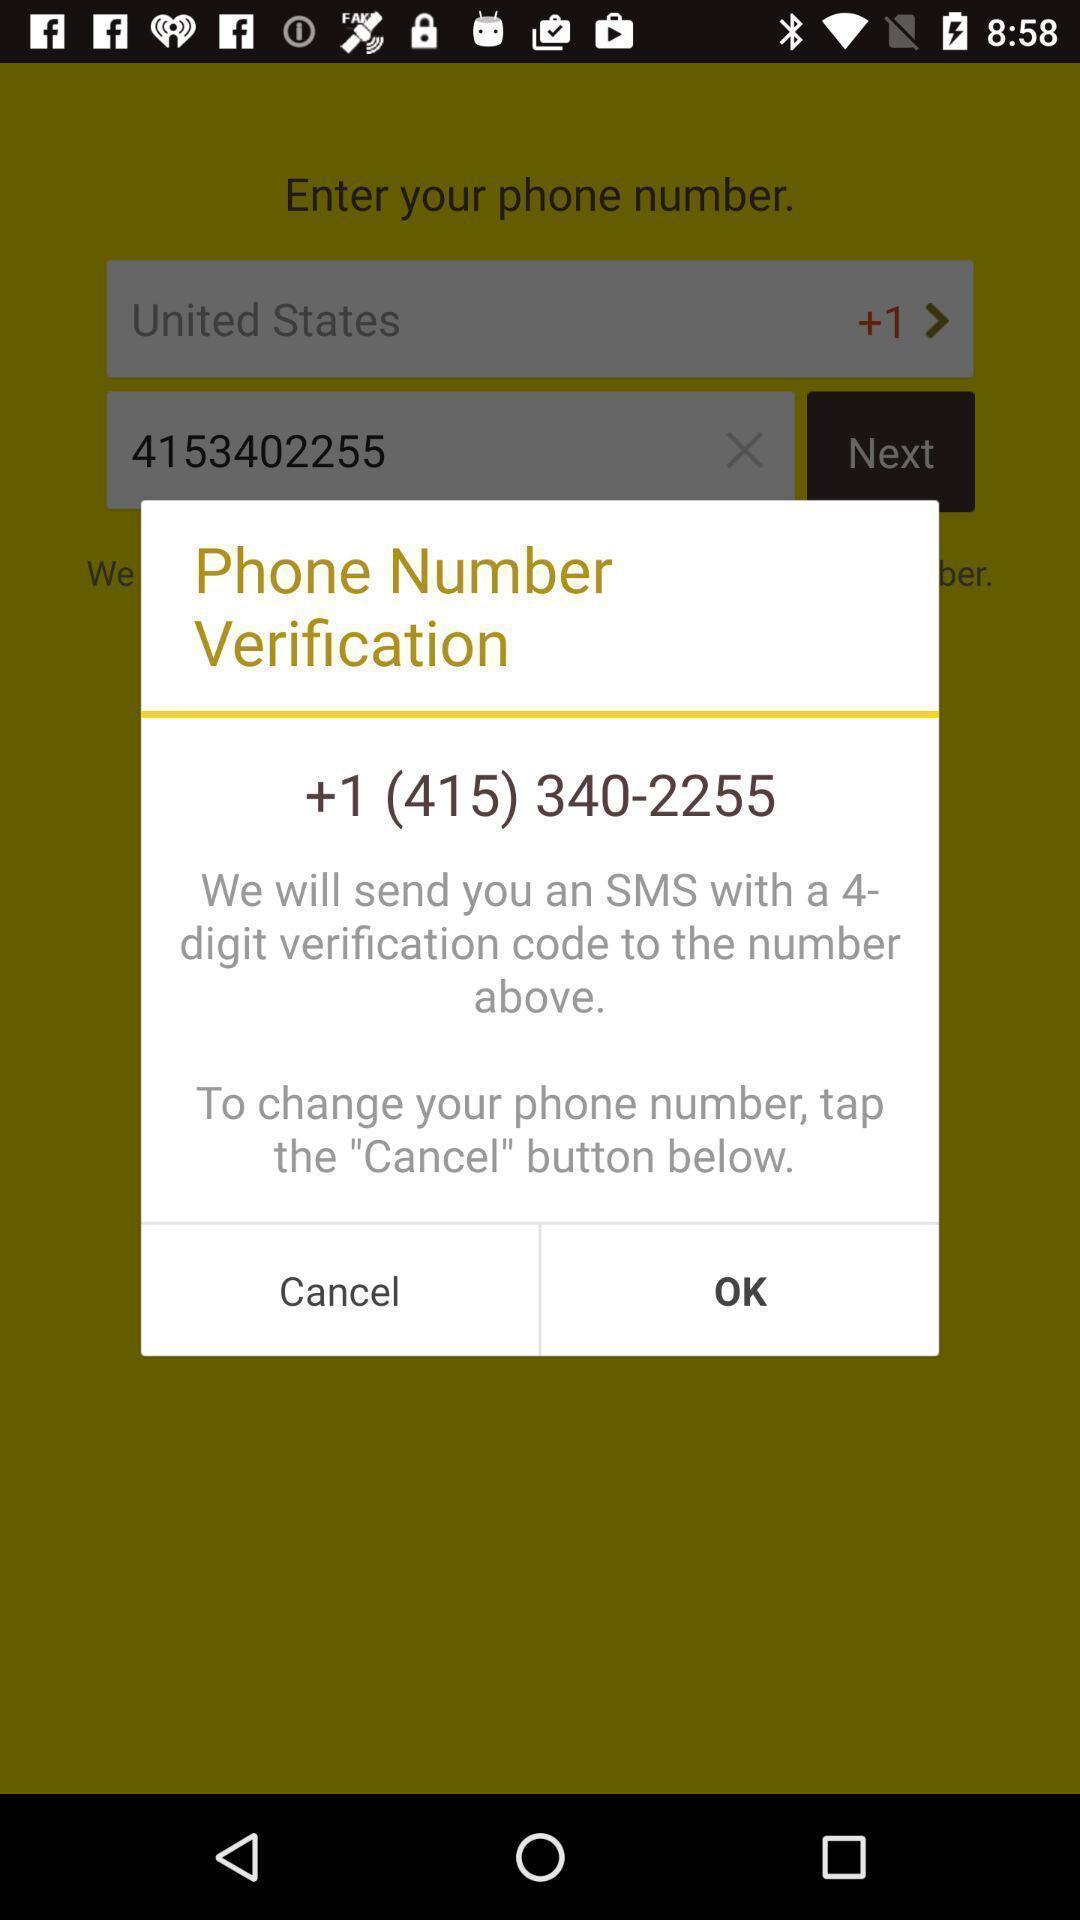Describe the key features of this screenshot. Popup to verify phone number. 